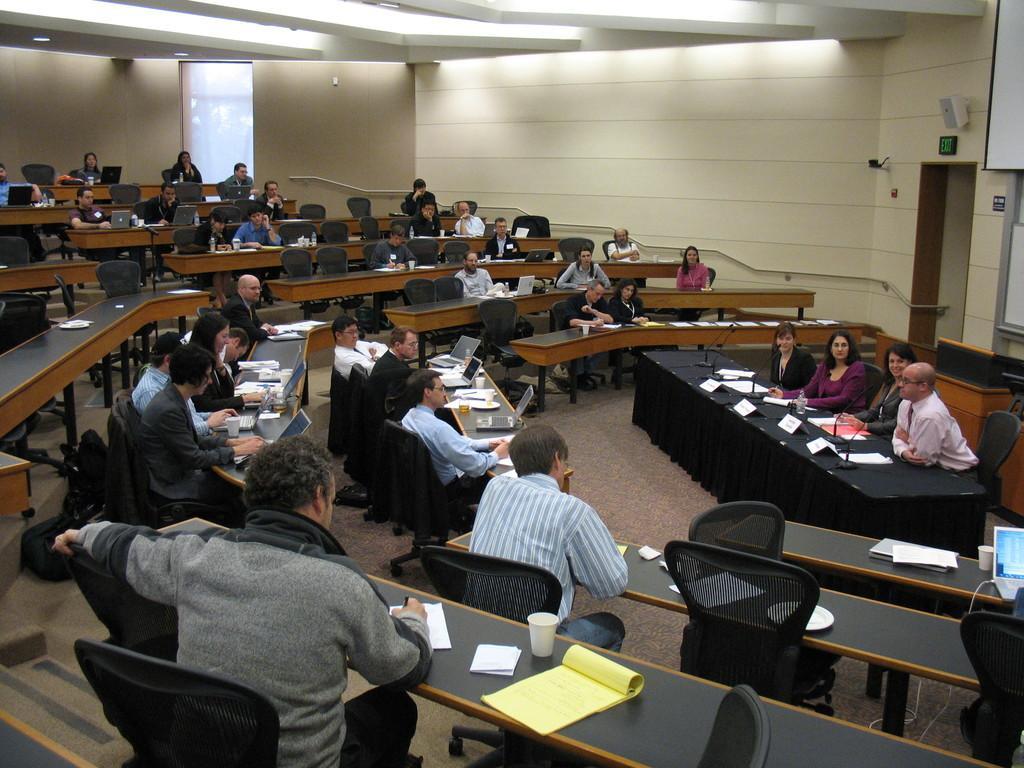Describe this image in one or two sentences. In this image there are many people On the right there is a table,cloth, in front of that there are four people sitting on the chair. On the left there is a man he wear jacket and trouser he is writing something. In the background there is a wall. 